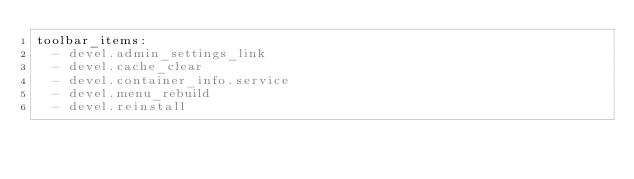Convert code to text. <code><loc_0><loc_0><loc_500><loc_500><_YAML_>toolbar_items:
  - devel.admin_settings_link
  - devel.cache_clear
  - devel.container_info.service
  - devel.menu_rebuild
  - devel.reinstall</code> 